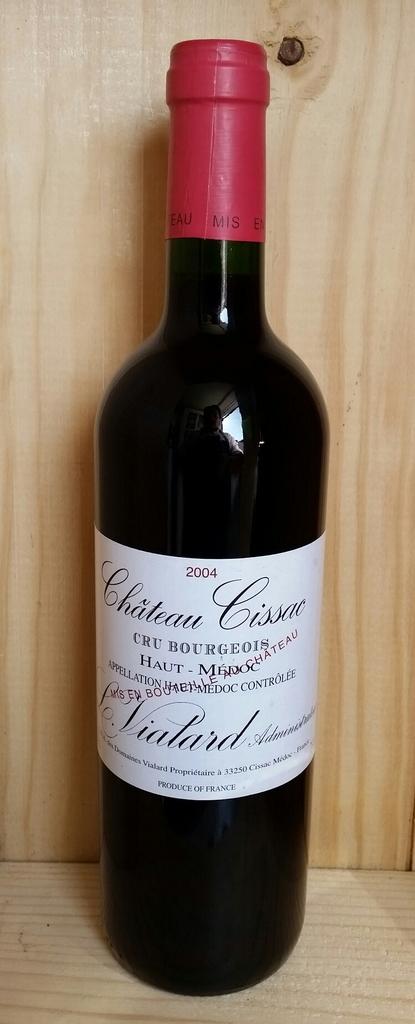Is this a 2004 bottle?
Make the answer very short. Yes. What brand is the wine?
Your answer should be compact. Chateau cissac. 